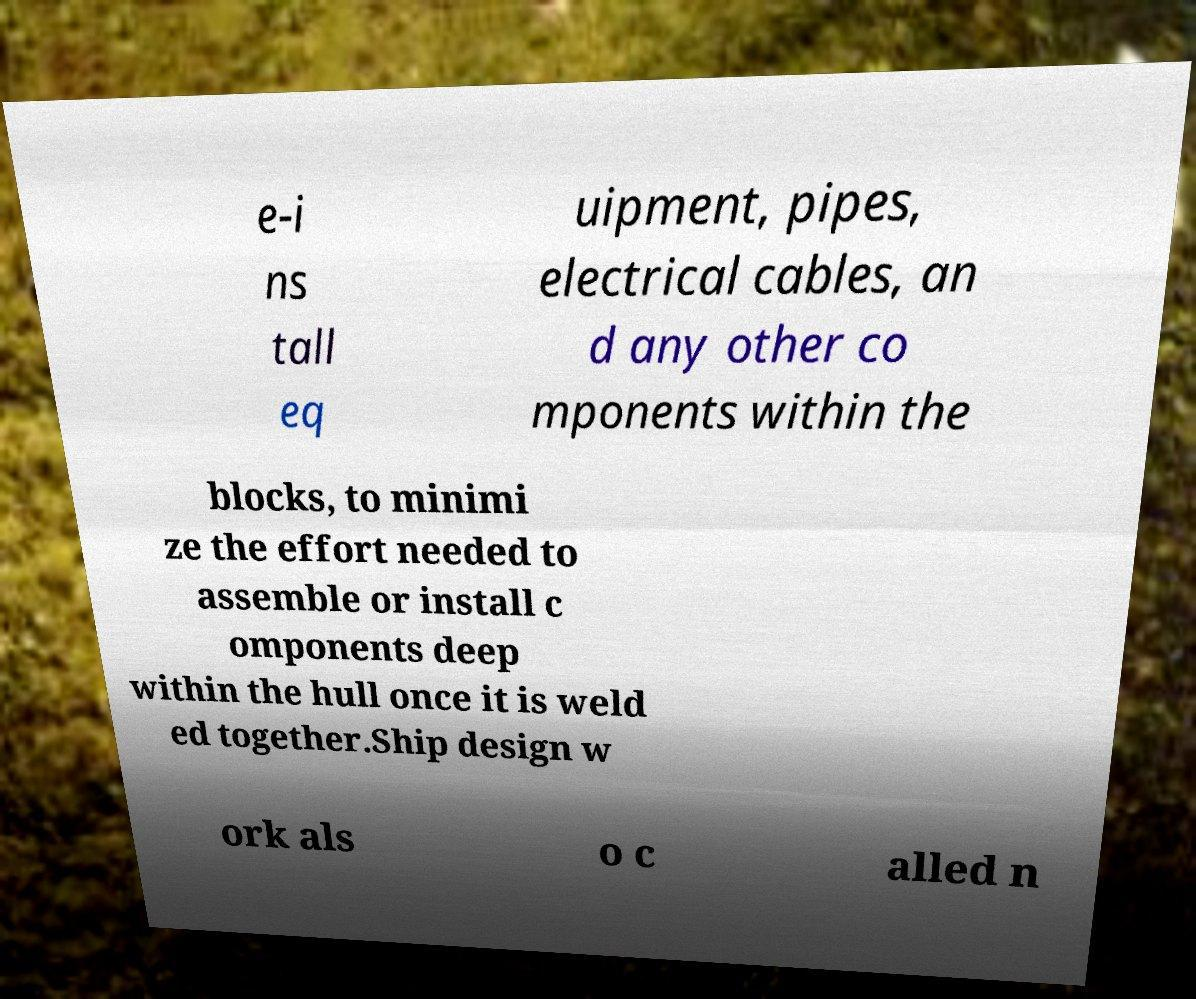Could you assist in decoding the text presented in this image and type it out clearly? e-i ns tall eq uipment, pipes, electrical cables, an d any other co mponents within the blocks, to minimi ze the effort needed to assemble or install c omponents deep within the hull once it is weld ed together.Ship design w ork als o c alled n 